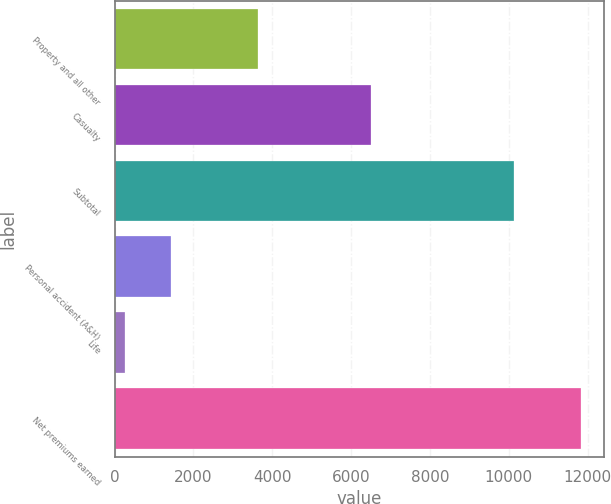Convert chart. <chart><loc_0><loc_0><loc_500><loc_500><bar_chart><fcel>Property and all other<fcel>Casualty<fcel>Subtotal<fcel>Personal accident (A&H)<fcel>Life<fcel>Net premiums earned<nl><fcel>3625<fcel>6506<fcel>10131<fcel>1429.1<fcel>274<fcel>11825<nl></chart> 